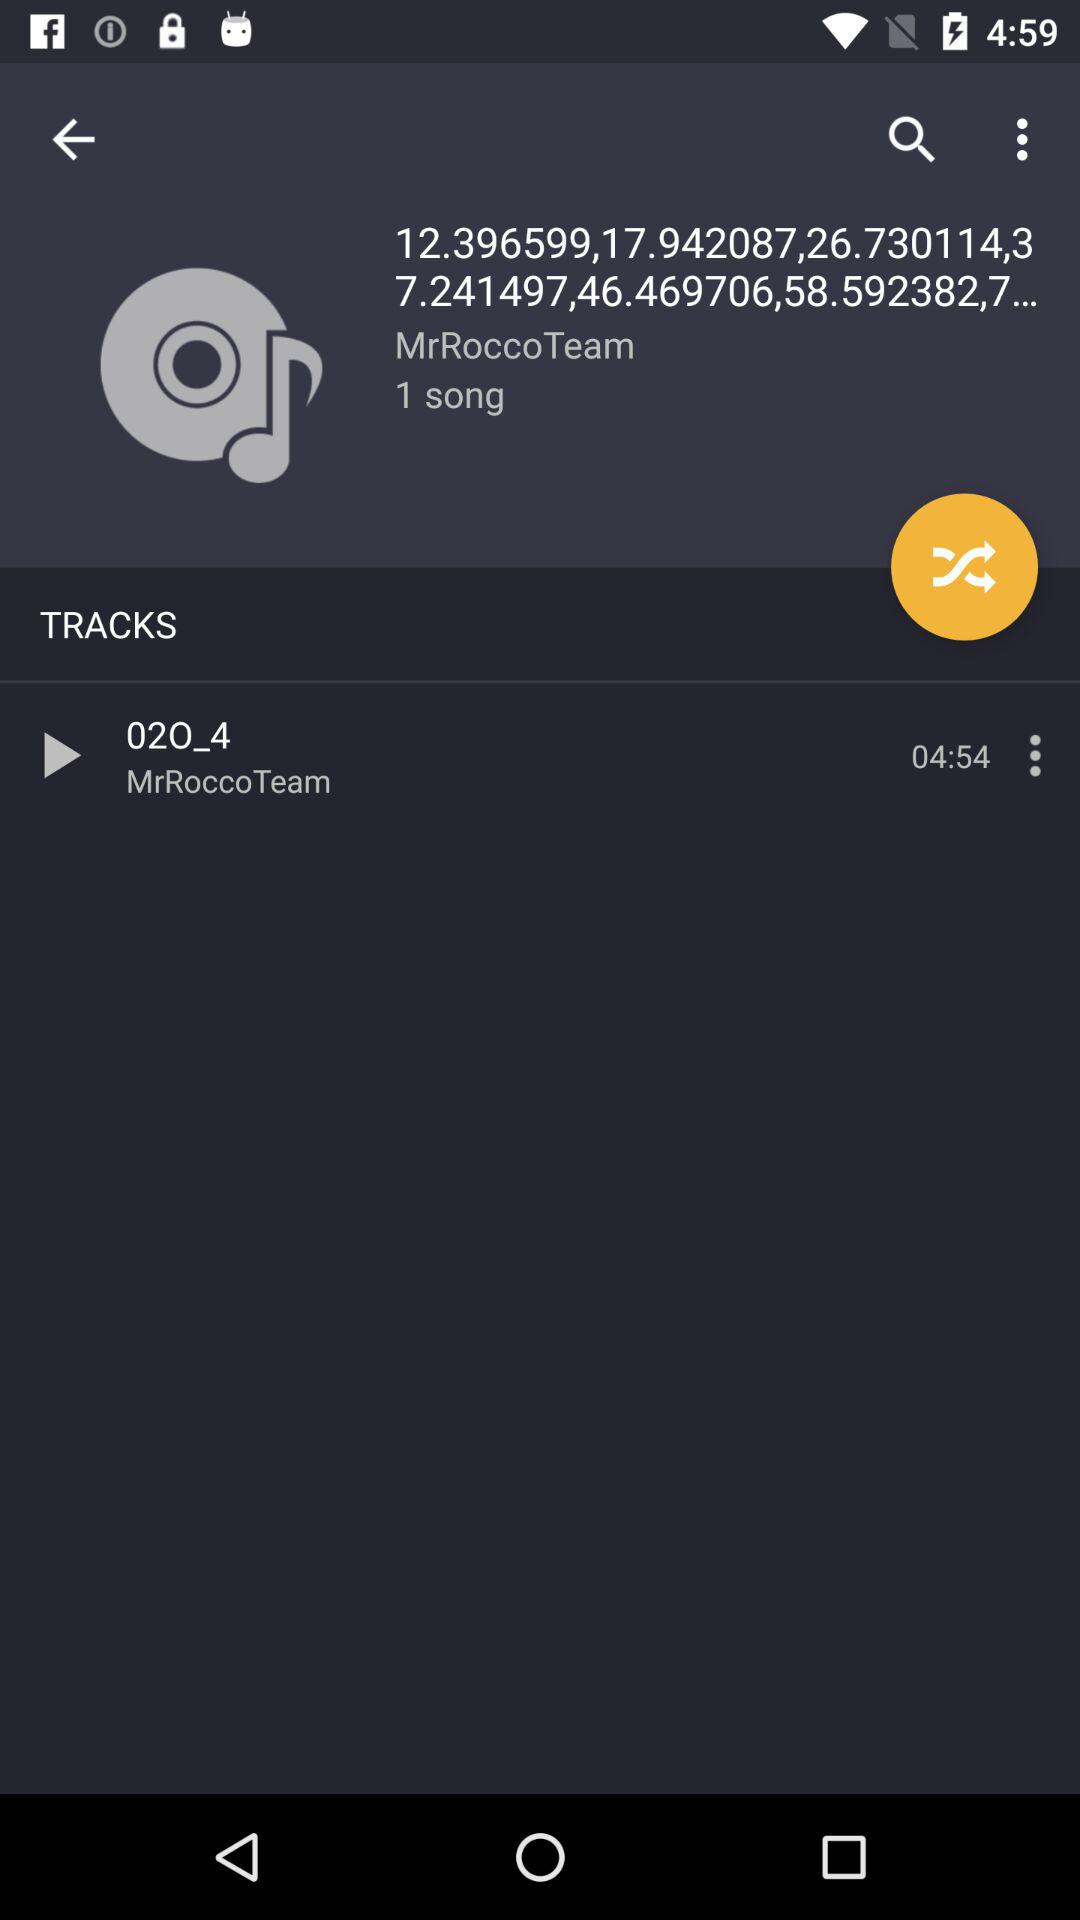What is the duration of the song? The duration of the song is 04:54. 